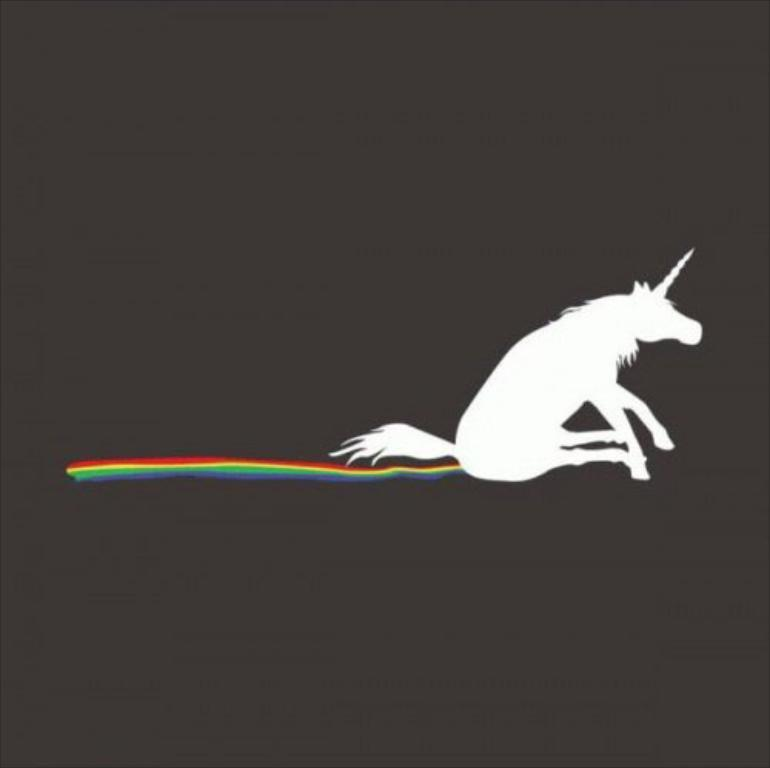What type of image is being described? The image is an edited image. What is the main subject of the image? There is a unicorn in the image. How is the unicorn depicted in terms of color? The unicorn has different colors. What is the color scheme of the background in the image? The background of the image is dark. What type of pest can be seen in the image? There is no pest present in the image; it features a unicorn with different colors against a dark background. How does the unicorn say good-bye in the image? The unicorn does not say good-bye in the image, as it is a static image and not an animation or video. 